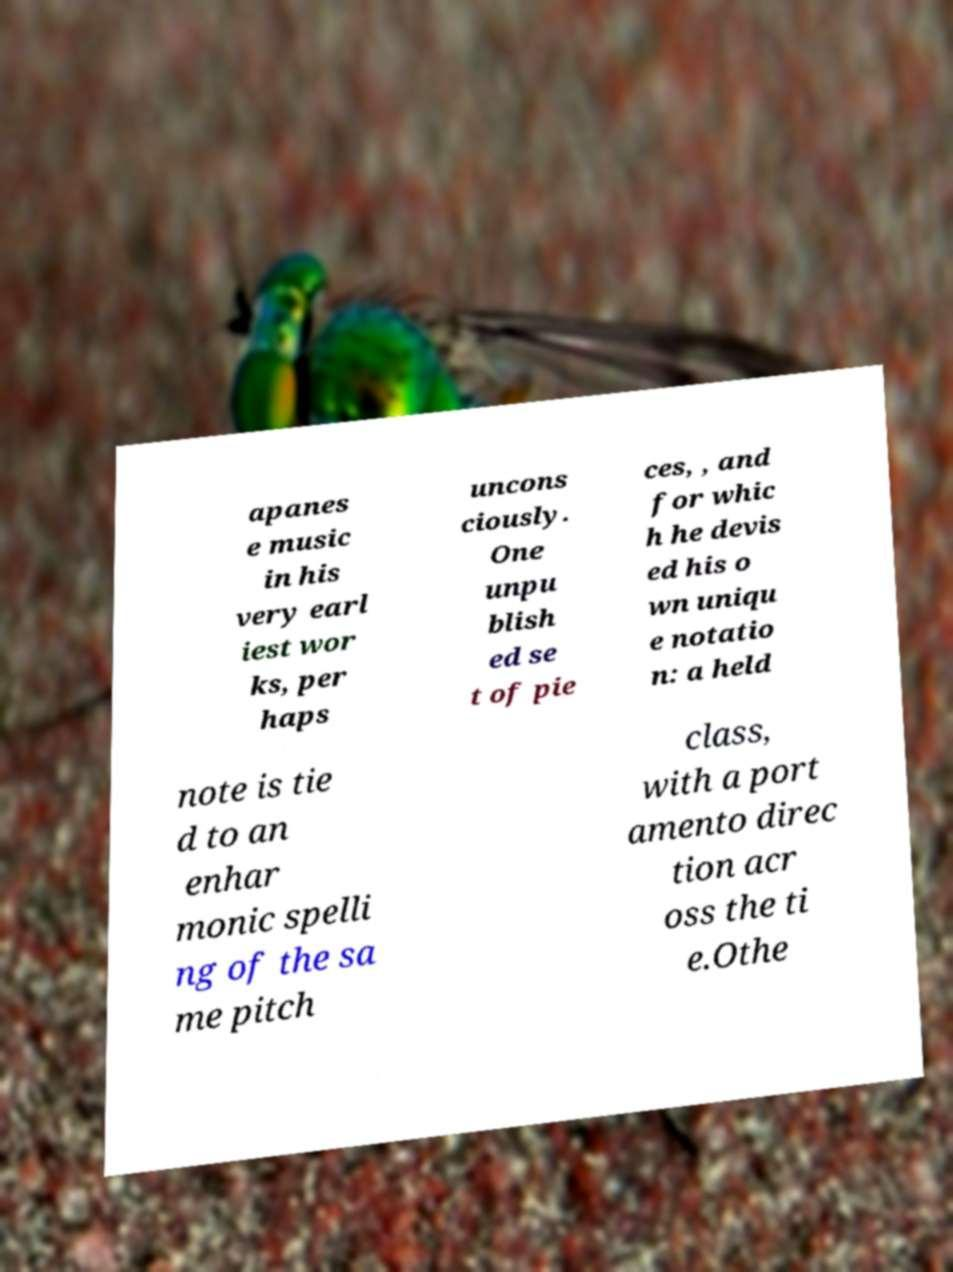I need the written content from this picture converted into text. Can you do that? apanes e music in his very earl iest wor ks, per haps uncons ciously. One unpu blish ed se t of pie ces, , and for whic h he devis ed his o wn uniqu e notatio n: a held note is tie d to an enhar monic spelli ng of the sa me pitch class, with a port amento direc tion acr oss the ti e.Othe 